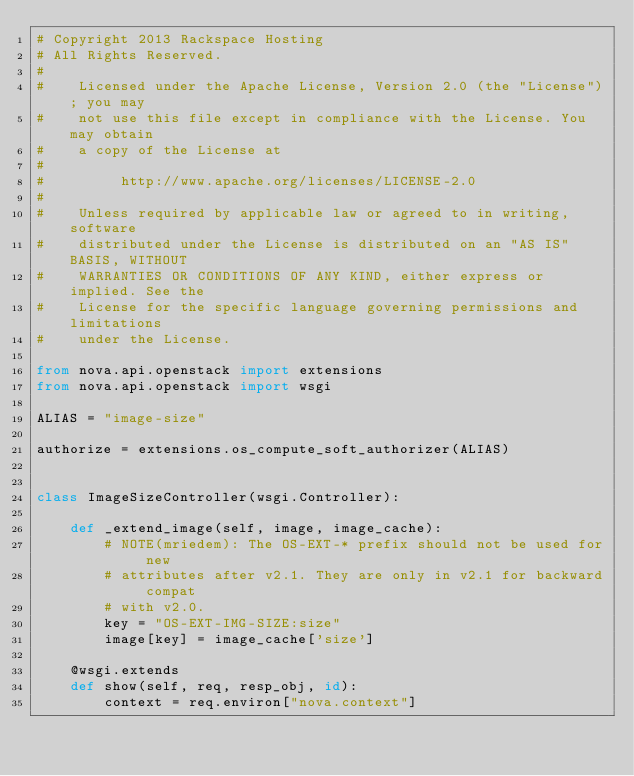<code> <loc_0><loc_0><loc_500><loc_500><_Python_># Copyright 2013 Rackspace Hosting
# All Rights Reserved.
#
#    Licensed under the Apache License, Version 2.0 (the "License"); you may
#    not use this file except in compliance with the License. You may obtain
#    a copy of the License at
#
#         http://www.apache.org/licenses/LICENSE-2.0
#
#    Unless required by applicable law or agreed to in writing, software
#    distributed under the License is distributed on an "AS IS" BASIS, WITHOUT
#    WARRANTIES OR CONDITIONS OF ANY KIND, either express or implied. See the
#    License for the specific language governing permissions and limitations
#    under the License.

from nova.api.openstack import extensions
from nova.api.openstack import wsgi

ALIAS = "image-size"

authorize = extensions.os_compute_soft_authorizer(ALIAS)


class ImageSizeController(wsgi.Controller):

    def _extend_image(self, image, image_cache):
        # NOTE(mriedem): The OS-EXT-* prefix should not be used for new
        # attributes after v2.1. They are only in v2.1 for backward compat
        # with v2.0.
        key = "OS-EXT-IMG-SIZE:size"
        image[key] = image_cache['size']

    @wsgi.extends
    def show(self, req, resp_obj, id):
        context = req.environ["nova.context"]</code> 